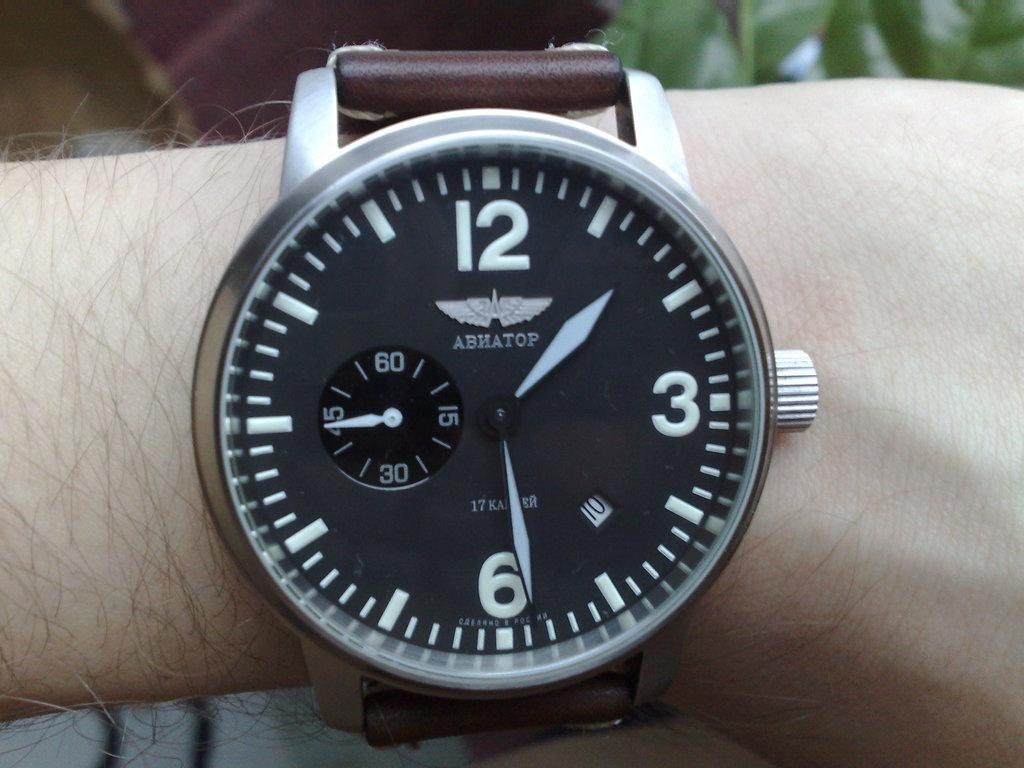<image>
Render a clear and concise summary of the photo. An ABHATOP wristwatch shows the time to be 1:29. 